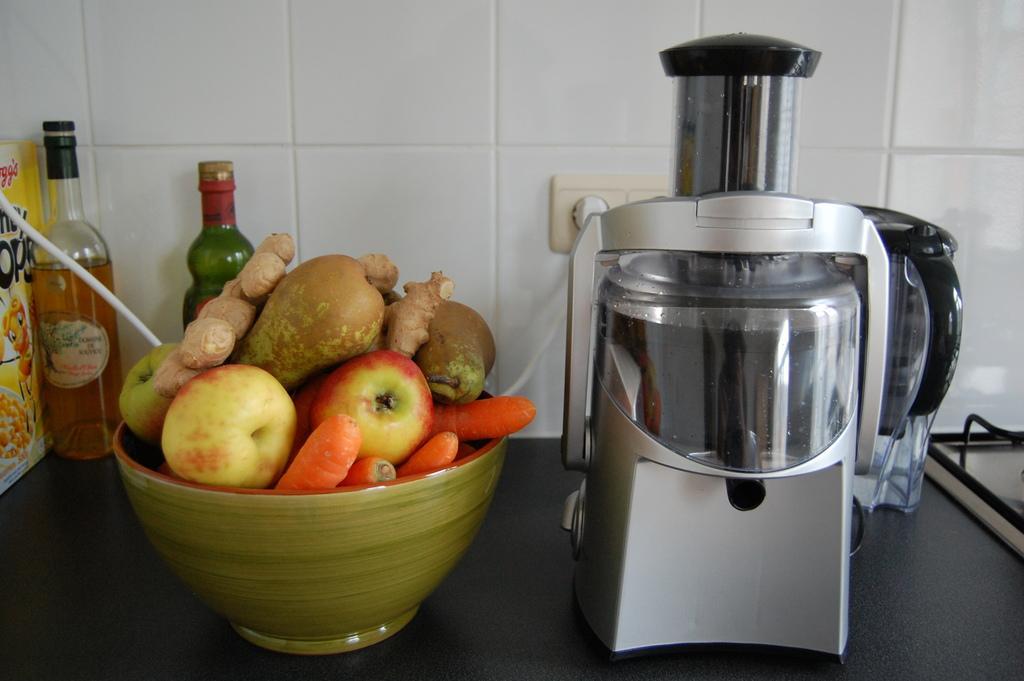Can you describe this image briefly? At the bottom of the image there is a platform. On the platform there is a mixer, bowl with ginger, apples, carrots and some other items in it. Behind the bowl there are bottles and also there is a packet. In the background there is a wall with tiles and switch board with wire. On the right corner of the image there is an object. 